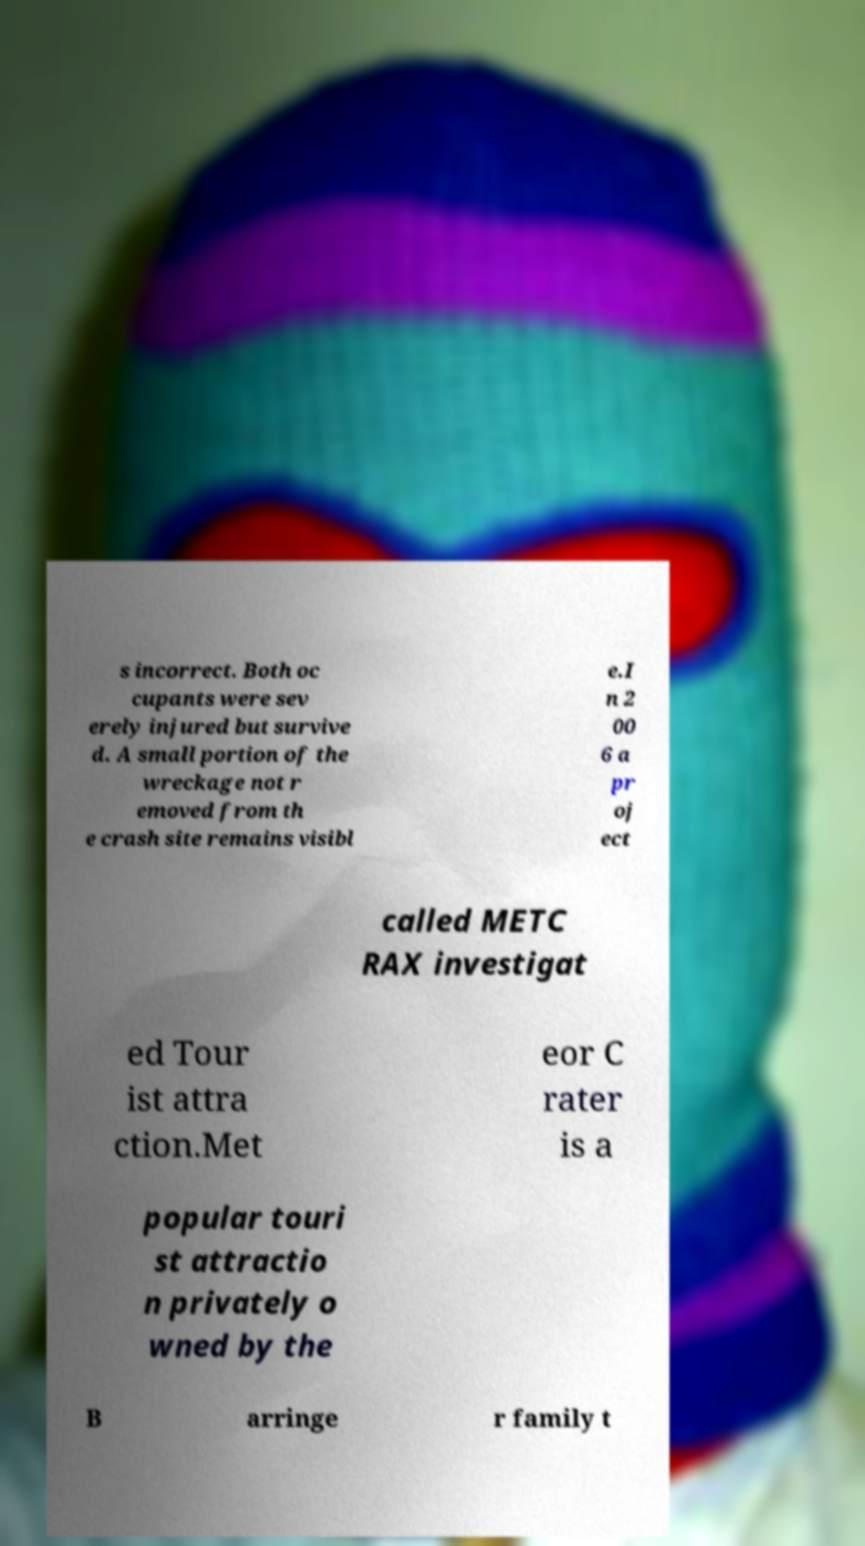I need the written content from this picture converted into text. Can you do that? s incorrect. Both oc cupants were sev erely injured but survive d. A small portion of the wreckage not r emoved from th e crash site remains visibl e.I n 2 00 6 a pr oj ect called METC RAX investigat ed Tour ist attra ction.Met eor C rater is a popular touri st attractio n privately o wned by the B arringe r family t 